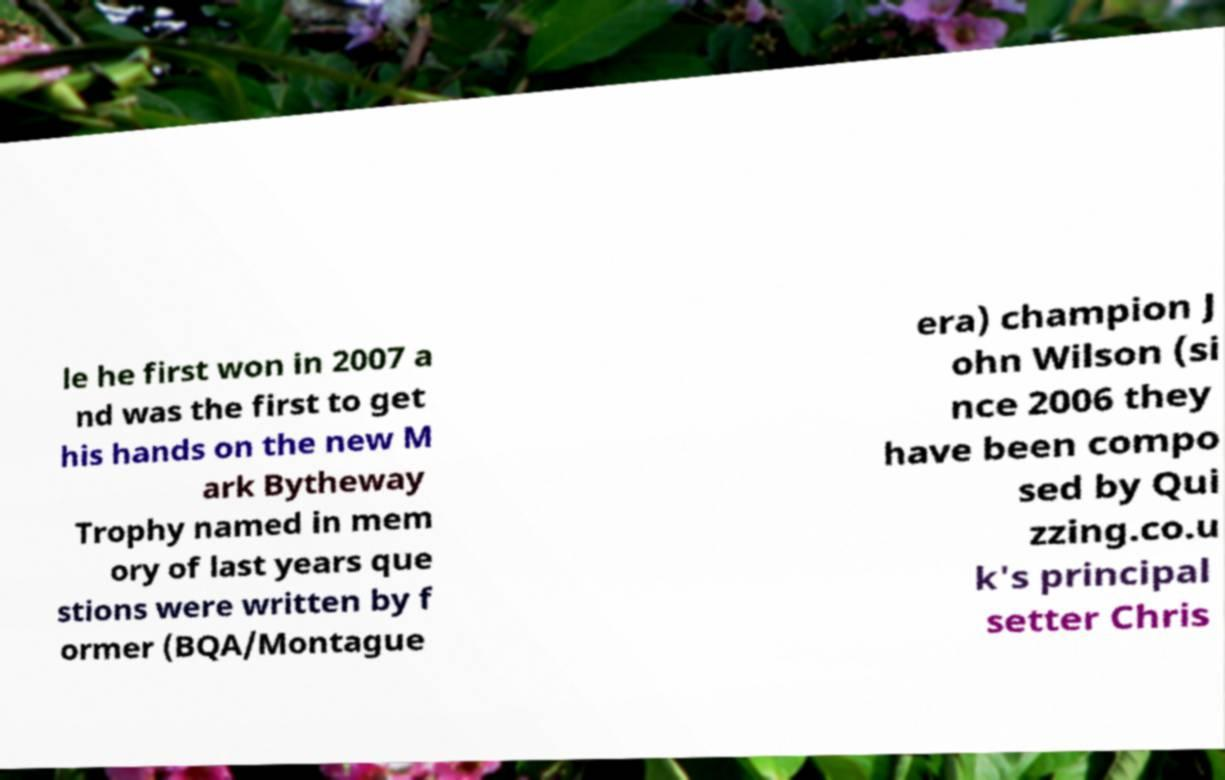Can you accurately transcribe the text from the provided image for me? le he first won in 2007 a nd was the first to get his hands on the new M ark Bytheway Trophy named in mem ory of last years que stions were written by f ormer (BQA/Montague era) champion J ohn Wilson (si nce 2006 they have been compo sed by Qui zzing.co.u k's principal setter Chris 